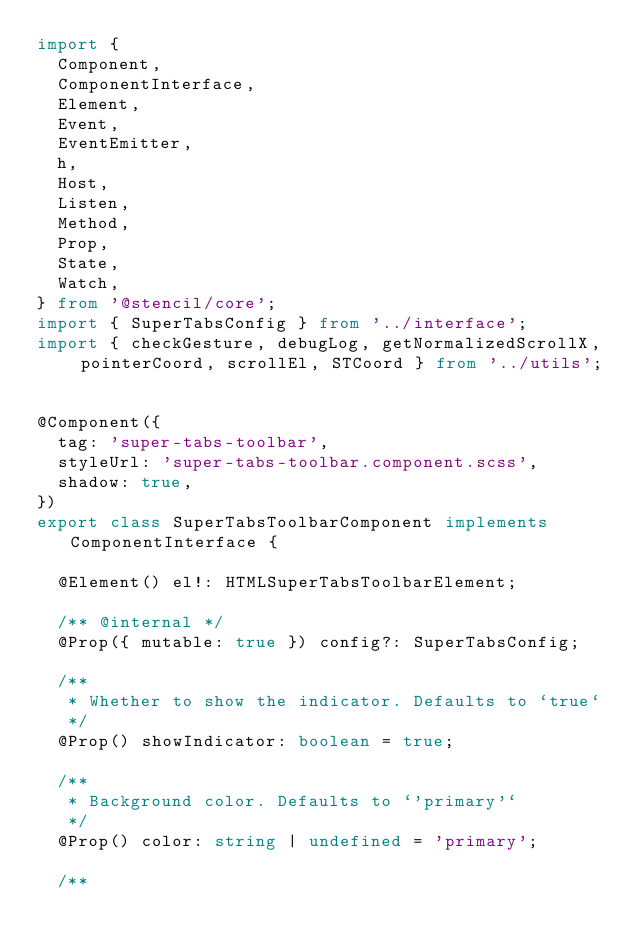Convert code to text. <code><loc_0><loc_0><loc_500><loc_500><_TypeScript_>import {
  Component,
  ComponentInterface,
  Element,
  Event,
  EventEmitter,
  h,
  Host,
  Listen,
  Method,
  Prop,
  State,
  Watch,
} from '@stencil/core';
import { SuperTabsConfig } from '../interface';
import { checkGesture, debugLog, getNormalizedScrollX, pointerCoord, scrollEl, STCoord } from '../utils';


@Component({
  tag: 'super-tabs-toolbar',
  styleUrl: 'super-tabs-toolbar.component.scss',
  shadow: true,
})
export class SuperTabsToolbarComponent implements ComponentInterface {

  @Element() el!: HTMLSuperTabsToolbarElement;

  /** @internal */
  @Prop({ mutable: true }) config?: SuperTabsConfig;

  /**
   * Whether to show the indicator. Defaults to `true`
   */
  @Prop() showIndicator: boolean = true;

  /**
   * Background color. Defaults to `'primary'`
   */
  @Prop() color: string | undefined = 'primary';

  /**</code> 